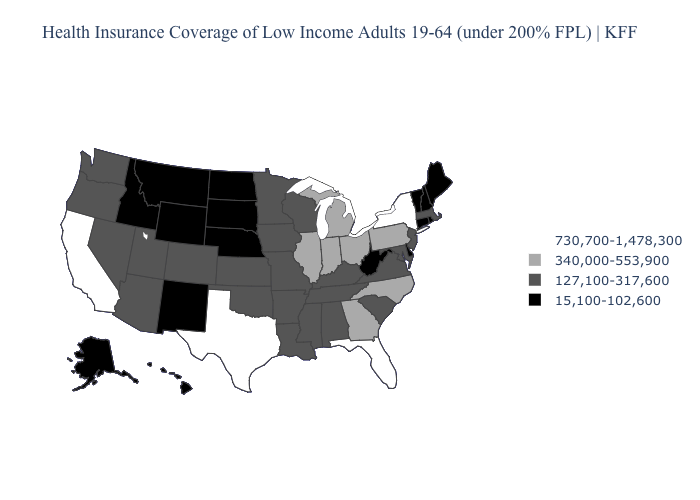Name the states that have a value in the range 730,700-1,478,300?
Quick response, please. California, Florida, New York, Texas. What is the value of Mississippi?
Give a very brief answer. 127,100-317,600. Name the states that have a value in the range 730,700-1,478,300?
Quick response, please. California, Florida, New York, Texas. Which states have the lowest value in the USA?
Concise answer only. Alaska, Connecticut, Delaware, Hawaii, Idaho, Maine, Montana, Nebraska, New Hampshire, New Mexico, North Dakota, Rhode Island, South Dakota, Vermont, West Virginia, Wyoming. Which states hav the highest value in the South?
Be succinct. Florida, Texas. Among the states that border New Hampshire , which have the highest value?
Give a very brief answer. Massachusetts. Does Washington have the highest value in the USA?
Quick response, please. No. What is the highest value in the South ?
Be succinct. 730,700-1,478,300. What is the value of West Virginia?
Keep it brief. 15,100-102,600. What is the value of Alabama?
Concise answer only. 127,100-317,600. What is the highest value in the USA?
Concise answer only. 730,700-1,478,300. Name the states that have a value in the range 127,100-317,600?
Quick response, please. Alabama, Arizona, Arkansas, Colorado, Iowa, Kansas, Kentucky, Louisiana, Maryland, Massachusetts, Minnesota, Mississippi, Missouri, Nevada, New Jersey, Oklahoma, Oregon, South Carolina, Tennessee, Utah, Virginia, Washington, Wisconsin. Name the states that have a value in the range 15,100-102,600?
Give a very brief answer. Alaska, Connecticut, Delaware, Hawaii, Idaho, Maine, Montana, Nebraska, New Hampshire, New Mexico, North Dakota, Rhode Island, South Dakota, Vermont, West Virginia, Wyoming. Name the states that have a value in the range 127,100-317,600?
Keep it brief. Alabama, Arizona, Arkansas, Colorado, Iowa, Kansas, Kentucky, Louisiana, Maryland, Massachusetts, Minnesota, Mississippi, Missouri, Nevada, New Jersey, Oklahoma, Oregon, South Carolina, Tennessee, Utah, Virginia, Washington, Wisconsin. What is the value of Maine?
Be succinct. 15,100-102,600. 